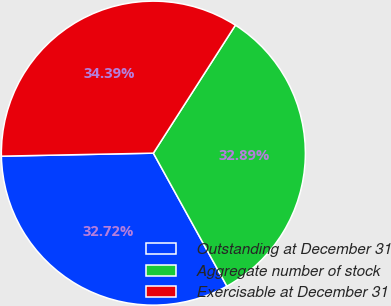Convert chart. <chart><loc_0><loc_0><loc_500><loc_500><pie_chart><fcel>Outstanding at December 31<fcel>Aggregate number of stock<fcel>Exercisable at December 31<nl><fcel>32.72%<fcel>32.89%<fcel>34.39%<nl></chart> 